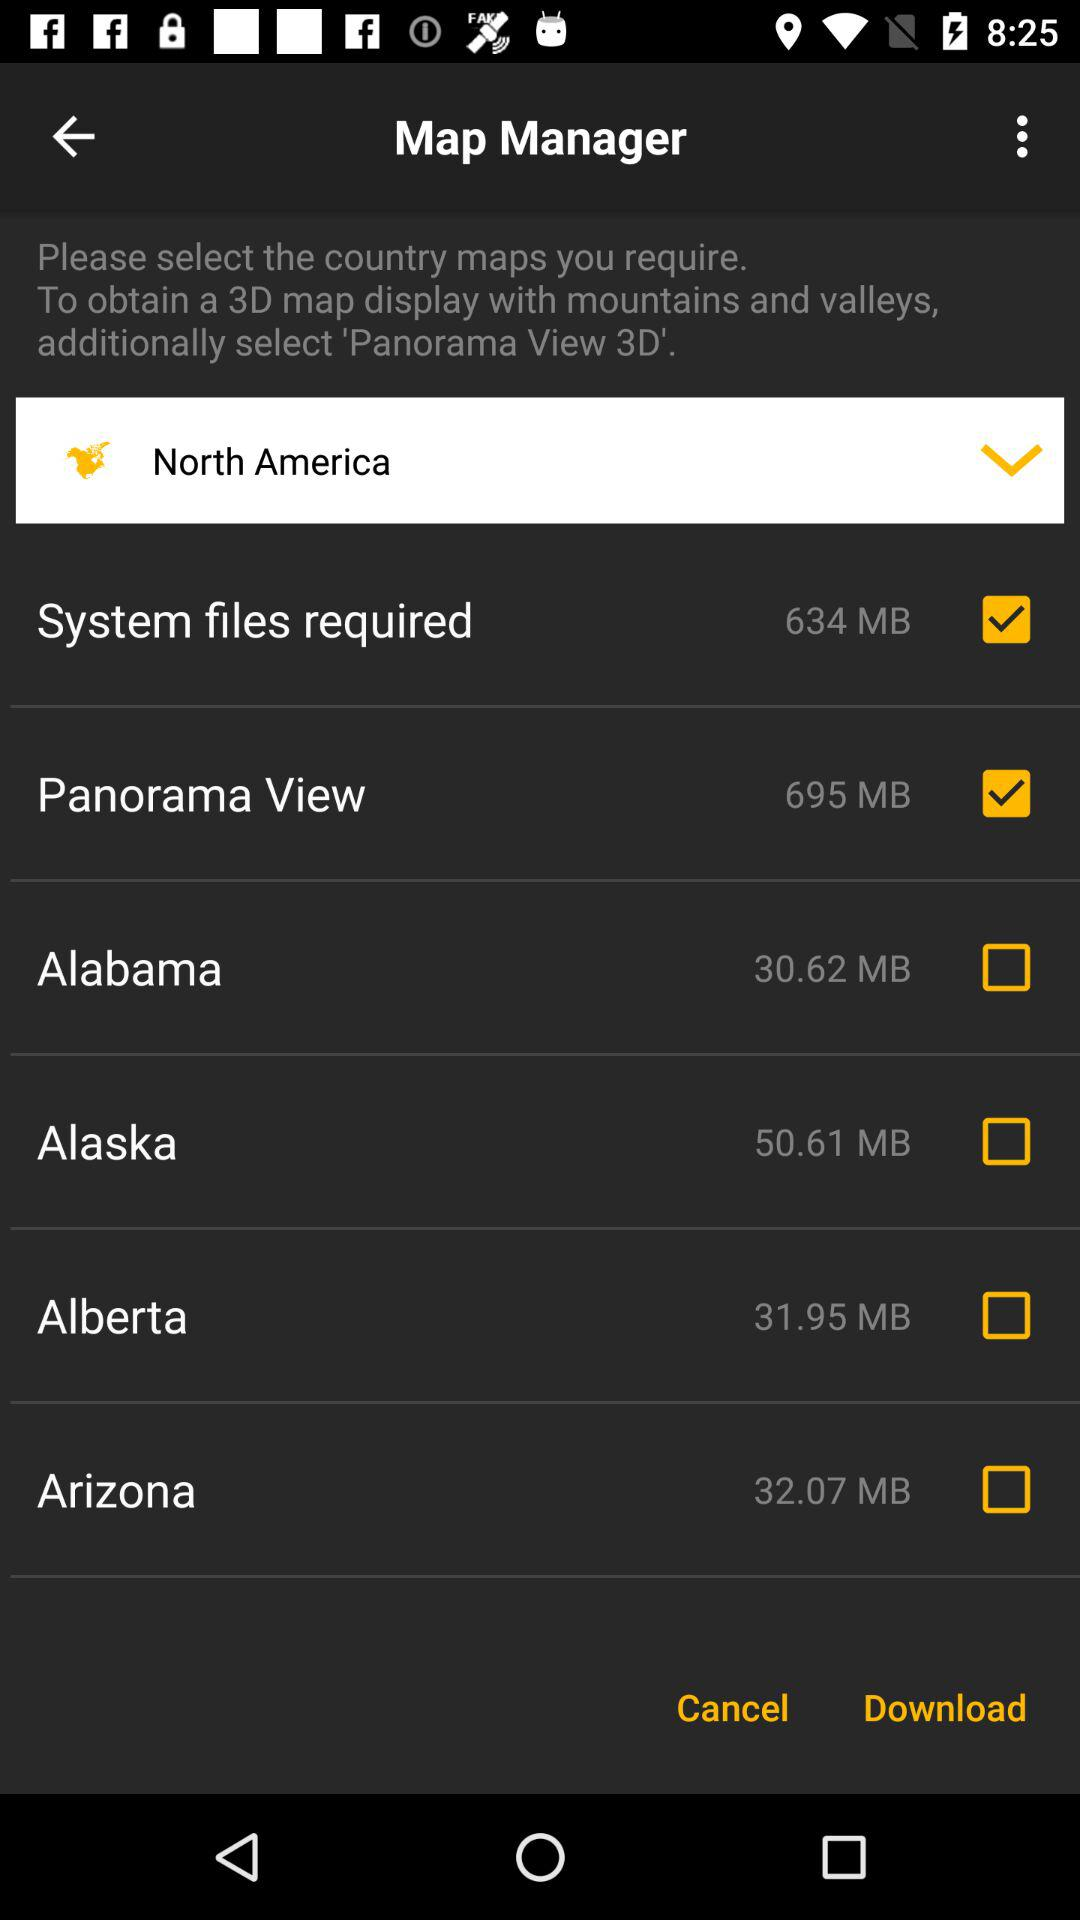What is the size of the "Panorama View"? The size of the "Panorama View" is 695 MB. 